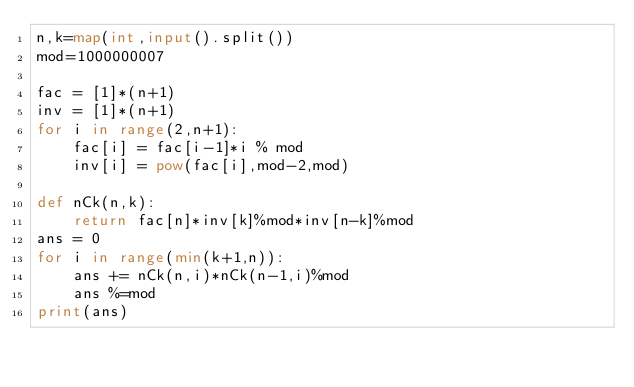Convert code to text. <code><loc_0><loc_0><loc_500><loc_500><_Python_>n,k=map(int,input().split())
mod=1000000007

fac = [1]*(n+1)
inv = [1]*(n+1)
for i in range(2,n+1):
    fac[i] = fac[i-1]*i % mod
    inv[i] = pow(fac[i],mod-2,mod)

def nCk(n,k):
    return fac[n]*inv[k]%mod*inv[n-k]%mod
ans = 0
for i in range(min(k+1,n)):
    ans += nCk(n,i)*nCk(n-1,i)%mod
    ans %=mod
print(ans)</code> 